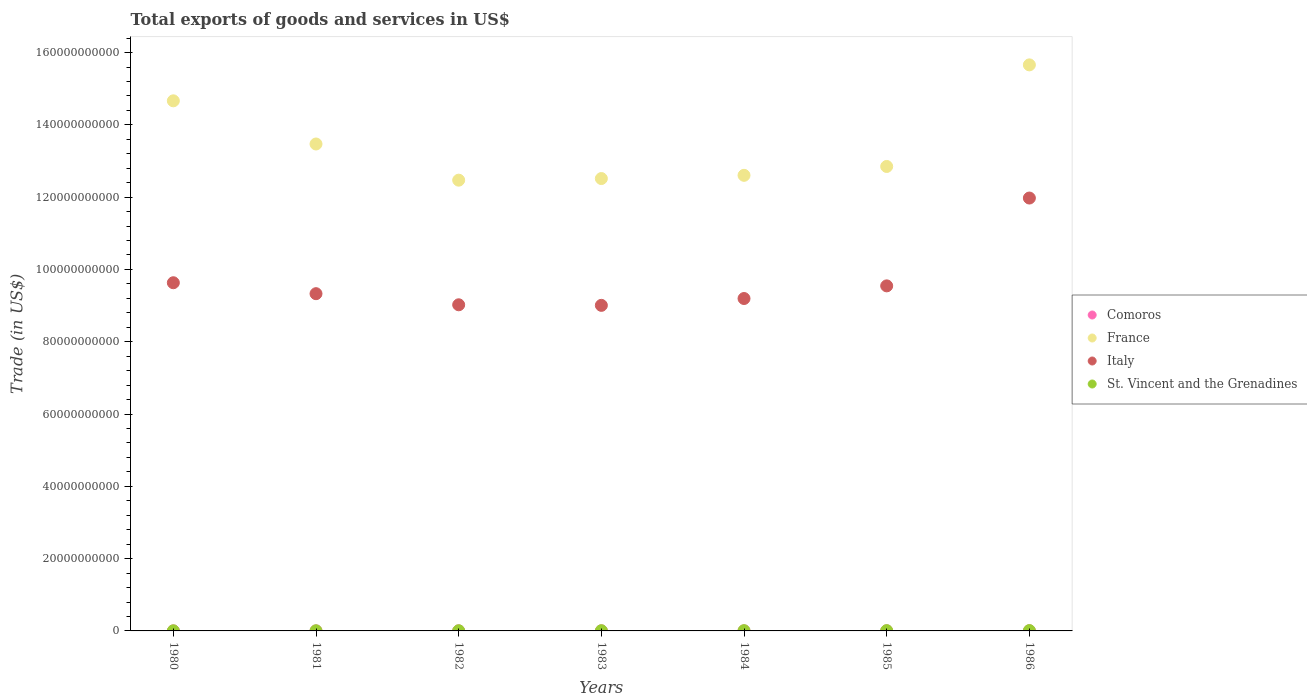Is the number of dotlines equal to the number of legend labels?
Offer a very short reply. Yes. What is the total exports of goods and services in St. Vincent and the Grenadines in 1984?
Your answer should be compact. 7.15e+07. Across all years, what is the maximum total exports of goods and services in Italy?
Offer a very short reply. 1.20e+11. Across all years, what is the minimum total exports of goods and services in Italy?
Offer a terse response. 9.01e+1. In which year was the total exports of goods and services in Italy maximum?
Offer a terse response. 1986. What is the total total exports of goods and services in France in the graph?
Provide a short and direct response. 9.42e+11. What is the difference between the total exports of goods and services in Italy in 1983 and that in 1986?
Offer a terse response. -2.97e+1. What is the difference between the total exports of goods and services in St. Vincent and the Grenadines in 1984 and the total exports of goods and services in Comoros in 1983?
Provide a short and direct response. 4.94e+07. What is the average total exports of goods and services in France per year?
Your response must be concise. 1.35e+11. In the year 1986, what is the difference between the total exports of goods and services in Comoros and total exports of goods and services in France?
Your answer should be very brief. -1.57e+11. In how many years, is the total exports of goods and services in France greater than 116000000000 US$?
Provide a succinct answer. 7. What is the ratio of the total exports of goods and services in Comoros in 1983 to that in 1984?
Keep it short and to the point. 2.28. Is the total exports of goods and services in France in 1981 less than that in 1982?
Your response must be concise. No. Is the difference between the total exports of goods and services in Comoros in 1983 and 1985 greater than the difference between the total exports of goods and services in France in 1983 and 1985?
Offer a very short reply. Yes. What is the difference between the highest and the second highest total exports of goods and services in Comoros?
Provide a short and direct response. 4.60e+06. What is the difference between the highest and the lowest total exports of goods and services in France?
Your response must be concise. 3.19e+1. In how many years, is the total exports of goods and services in Italy greater than the average total exports of goods and services in Italy taken over all years?
Your answer should be very brief. 1. Is it the case that in every year, the sum of the total exports of goods and services in Italy and total exports of goods and services in France  is greater than the sum of total exports of goods and services in St. Vincent and the Grenadines and total exports of goods and services in Comoros?
Offer a very short reply. No. Is it the case that in every year, the sum of the total exports of goods and services in St. Vincent and the Grenadines and total exports of goods and services in France  is greater than the total exports of goods and services in Comoros?
Give a very brief answer. Yes. Does the total exports of goods and services in France monotonically increase over the years?
Keep it short and to the point. No. How many dotlines are there?
Make the answer very short. 4. How many years are there in the graph?
Your answer should be compact. 7. Does the graph contain grids?
Provide a succinct answer. No. How many legend labels are there?
Provide a succinct answer. 4. How are the legend labels stacked?
Ensure brevity in your answer.  Vertical. What is the title of the graph?
Ensure brevity in your answer.  Total exports of goods and services in US$. Does "New Caledonia" appear as one of the legend labels in the graph?
Ensure brevity in your answer.  No. What is the label or title of the X-axis?
Offer a very short reply. Years. What is the label or title of the Y-axis?
Your answer should be compact. Trade (in US$). What is the Trade (in US$) in Comoros in 1980?
Make the answer very short. 1.07e+07. What is the Trade (in US$) of France in 1980?
Ensure brevity in your answer.  1.47e+11. What is the Trade (in US$) of Italy in 1980?
Give a very brief answer. 9.63e+1. What is the Trade (in US$) in St. Vincent and the Grenadines in 1980?
Offer a very short reply. 3.31e+07. What is the Trade (in US$) in Comoros in 1981?
Your answer should be compact. 1.34e+07. What is the Trade (in US$) of France in 1981?
Provide a short and direct response. 1.35e+11. What is the Trade (in US$) of Italy in 1981?
Your answer should be compact. 9.33e+1. What is the Trade (in US$) of St. Vincent and the Grenadines in 1981?
Make the answer very short. 4.30e+07. What is the Trade (in US$) of Comoros in 1982?
Provide a short and direct response. 1.68e+07. What is the Trade (in US$) in France in 1982?
Provide a succinct answer. 1.25e+11. What is the Trade (in US$) of Italy in 1982?
Provide a succinct answer. 9.02e+1. What is the Trade (in US$) of St. Vincent and the Grenadines in 1982?
Give a very brief answer. 5.03e+07. What is the Trade (in US$) of Comoros in 1983?
Keep it short and to the point. 2.21e+07. What is the Trade (in US$) in France in 1983?
Your response must be concise. 1.25e+11. What is the Trade (in US$) in Italy in 1983?
Offer a very short reply. 9.01e+1. What is the Trade (in US$) in St. Vincent and the Grenadines in 1983?
Provide a succinct answer. 5.77e+07. What is the Trade (in US$) of Comoros in 1984?
Your answer should be compact. 9.69e+06. What is the Trade (in US$) of France in 1984?
Offer a terse response. 1.26e+11. What is the Trade (in US$) of Italy in 1984?
Offer a terse response. 9.20e+1. What is the Trade (in US$) of St. Vincent and the Grenadines in 1984?
Provide a succinct answer. 7.15e+07. What is the Trade (in US$) of Comoros in 1985?
Ensure brevity in your answer.  1.95e+07. What is the Trade (in US$) in France in 1985?
Offer a terse response. 1.28e+11. What is the Trade (in US$) in Italy in 1985?
Keep it short and to the point. 9.55e+1. What is the Trade (in US$) in St. Vincent and the Grenadines in 1985?
Your response must be concise. 8.24e+07. What is the Trade (in US$) in Comoros in 1986?
Ensure brevity in your answer.  2.67e+07. What is the Trade (in US$) in France in 1986?
Offer a terse response. 1.57e+11. What is the Trade (in US$) of Italy in 1986?
Your answer should be very brief. 1.20e+11. What is the Trade (in US$) of St. Vincent and the Grenadines in 1986?
Keep it short and to the point. 9.29e+07. Across all years, what is the maximum Trade (in US$) of Comoros?
Give a very brief answer. 2.67e+07. Across all years, what is the maximum Trade (in US$) in France?
Offer a terse response. 1.57e+11. Across all years, what is the maximum Trade (in US$) of Italy?
Provide a succinct answer. 1.20e+11. Across all years, what is the maximum Trade (in US$) in St. Vincent and the Grenadines?
Your response must be concise. 9.29e+07. Across all years, what is the minimum Trade (in US$) in Comoros?
Your response must be concise. 9.69e+06. Across all years, what is the minimum Trade (in US$) of France?
Your response must be concise. 1.25e+11. Across all years, what is the minimum Trade (in US$) in Italy?
Give a very brief answer. 9.01e+1. Across all years, what is the minimum Trade (in US$) of St. Vincent and the Grenadines?
Your answer should be compact. 3.31e+07. What is the total Trade (in US$) of Comoros in the graph?
Provide a succinct answer. 1.19e+08. What is the total Trade (in US$) in France in the graph?
Your response must be concise. 9.42e+11. What is the total Trade (in US$) in Italy in the graph?
Give a very brief answer. 6.77e+11. What is the total Trade (in US$) of St. Vincent and the Grenadines in the graph?
Give a very brief answer. 4.31e+08. What is the difference between the Trade (in US$) of Comoros in 1980 and that in 1981?
Make the answer very short. -2.69e+06. What is the difference between the Trade (in US$) in France in 1980 and that in 1981?
Make the answer very short. 1.19e+1. What is the difference between the Trade (in US$) of Italy in 1980 and that in 1981?
Offer a very short reply. 3.03e+09. What is the difference between the Trade (in US$) in St. Vincent and the Grenadines in 1980 and that in 1981?
Your answer should be compact. -9.82e+06. What is the difference between the Trade (in US$) in Comoros in 1980 and that in 1982?
Your answer should be very brief. -6.05e+06. What is the difference between the Trade (in US$) in France in 1980 and that in 1982?
Provide a succinct answer. 2.19e+1. What is the difference between the Trade (in US$) of Italy in 1980 and that in 1982?
Offer a terse response. 6.10e+09. What is the difference between the Trade (in US$) of St. Vincent and the Grenadines in 1980 and that in 1982?
Ensure brevity in your answer.  -1.72e+07. What is the difference between the Trade (in US$) of Comoros in 1980 and that in 1983?
Ensure brevity in your answer.  -1.14e+07. What is the difference between the Trade (in US$) of France in 1980 and that in 1983?
Provide a short and direct response. 2.15e+1. What is the difference between the Trade (in US$) in Italy in 1980 and that in 1983?
Ensure brevity in your answer.  6.25e+09. What is the difference between the Trade (in US$) in St. Vincent and the Grenadines in 1980 and that in 1983?
Offer a terse response. -2.45e+07. What is the difference between the Trade (in US$) of Comoros in 1980 and that in 1984?
Your answer should be very brief. 1.05e+06. What is the difference between the Trade (in US$) in France in 1980 and that in 1984?
Provide a short and direct response. 2.06e+1. What is the difference between the Trade (in US$) of Italy in 1980 and that in 1984?
Offer a very short reply. 4.36e+09. What is the difference between the Trade (in US$) of St. Vincent and the Grenadines in 1980 and that in 1984?
Ensure brevity in your answer.  -3.83e+07. What is the difference between the Trade (in US$) of Comoros in 1980 and that in 1985?
Make the answer very short. -8.72e+06. What is the difference between the Trade (in US$) of France in 1980 and that in 1985?
Provide a succinct answer. 1.82e+1. What is the difference between the Trade (in US$) in Italy in 1980 and that in 1985?
Your answer should be compact. 8.65e+08. What is the difference between the Trade (in US$) of St. Vincent and the Grenadines in 1980 and that in 1985?
Your response must be concise. -4.93e+07. What is the difference between the Trade (in US$) of Comoros in 1980 and that in 1986?
Your response must be concise. -1.60e+07. What is the difference between the Trade (in US$) of France in 1980 and that in 1986?
Your answer should be very brief. -9.95e+09. What is the difference between the Trade (in US$) in Italy in 1980 and that in 1986?
Your answer should be very brief. -2.34e+1. What is the difference between the Trade (in US$) of St. Vincent and the Grenadines in 1980 and that in 1986?
Offer a very short reply. -5.98e+07. What is the difference between the Trade (in US$) in Comoros in 1981 and that in 1982?
Your answer should be compact. -3.36e+06. What is the difference between the Trade (in US$) of France in 1981 and that in 1982?
Ensure brevity in your answer.  1.00e+1. What is the difference between the Trade (in US$) of Italy in 1981 and that in 1982?
Make the answer very short. 3.07e+09. What is the difference between the Trade (in US$) in St. Vincent and the Grenadines in 1981 and that in 1982?
Provide a succinct answer. -7.39e+06. What is the difference between the Trade (in US$) of Comoros in 1981 and that in 1983?
Give a very brief answer. -8.68e+06. What is the difference between the Trade (in US$) in France in 1981 and that in 1983?
Ensure brevity in your answer.  9.56e+09. What is the difference between the Trade (in US$) in Italy in 1981 and that in 1983?
Provide a short and direct response. 3.23e+09. What is the difference between the Trade (in US$) in St. Vincent and the Grenadines in 1981 and that in 1983?
Ensure brevity in your answer.  -1.47e+07. What is the difference between the Trade (in US$) in Comoros in 1981 and that in 1984?
Offer a terse response. 3.74e+06. What is the difference between the Trade (in US$) in France in 1981 and that in 1984?
Make the answer very short. 8.67e+09. What is the difference between the Trade (in US$) in Italy in 1981 and that in 1984?
Provide a short and direct response. 1.34e+09. What is the difference between the Trade (in US$) in St. Vincent and the Grenadines in 1981 and that in 1984?
Offer a very short reply. -2.85e+07. What is the difference between the Trade (in US$) in Comoros in 1981 and that in 1985?
Make the answer very short. -6.02e+06. What is the difference between the Trade (in US$) in France in 1981 and that in 1985?
Your answer should be compact. 6.22e+09. What is the difference between the Trade (in US$) in Italy in 1981 and that in 1985?
Your answer should be compact. -2.16e+09. What is the difference between the Trade (in US$) in St. Vincent and the Grenadines in 1981 and that in 1985?
Keep it short and to the point. -3.94e+07. What is the difference between the Trade (in US$) of Comoros in 1981 and that in 1986?
Your response must be concise. -1.33e+07. What is the difference between the Trade (in US$) of France in 1981 and that in 1986?
Make the answer very short. -2.19e+1. What is the difference between the Trade (in US$) of Italy in 1981 and that in 1986?
Your response must be concise. -2.65e+1. What is the difference between the Trade (in US$) in St. Vincent and the Grenadines in 1981 and that in 1986?
Provide a succinct answer. -4.99e+07. What is the difference between the Trade (in US$) of Comoros in 1982 and that in 1983?
Offer a very short reply. -5.31e+06. What is the difference between the Trade (in US$) of France in 1982 and that in 1983?
Keep it short and to the point. -4.46e+08. What is the difference between the Trade (in US$) of Italy in 1982 and that in 1983?
Offer a terse response. 1.56e+08. What is the difference between the Trade (in US$) of St. Vincent and the Grenadines in 1982 and that in 1983?
Provide a short and direct response. -7.34e+06. What is the difference between the Trade (in US$) of Comoros in 1982 and that in 1984?
Make the answer very short. 7.10e+06. What is the difference between the Trade (in US$) of France in 1982 and that in 1984?
Your answer should be very brief. -1.34e+09. What is the difference between the Trade (in US$) of Italy in 1982 and that in 1984?
Make the answer very short. -1.74e+09. What is the difference between the Trade (in US$) of St. Vincent and the Grenadines in 1982 and that in 1984?
Your response must be concise. -2.11e+07. What is the difference between the Trade (in US$) in Comoros in 1982 and that in 1985?
Make the answer very short. -2.66e+06. What is the difference between the Trade (in US$) of France in 1982 and that in 1985?
Ensure brevity in your answer.  -3.79e+09. What is the difference between the Trade (in US$) in Italy in 1982 and that in 1985?
Your response must be concise. -5.23e+09. What is the difference between the Trade (in US$) of St. Vincent and the Grenadines in 1982 and that in 1985?
Offer a terse response. -3.21e+07. What is the difference between the Trade (in US$) in Comoros in 1982 and that in 1986?
Offer a terse response. -9.92e+06. What is the difference between the Trade (in US$) in France in 1982 and that in 1986?
Provide a short and direct response. -3.19e+1. What is the difference between the Trade (in US$) in Italy in 1982 and that in 1986?
Your answer should be compact. -2.95e+1. What is the difference between the Trade (in US$) in St. Vincent and the Grenadines in 1982 and that in 1986?
Your response must be concise. -4.25e+07. What is the difference between the Trade (in US$) of Comoros in 1983 and that in 1984?
Offer a terse response. 1.24e+07. What is the difference between the Trade (in US$) in France in 1983 and that in 1984?
Your answer should be compact. -8.93e+08. What is the difference between the Trade (in US$) in Italy in 1983 and that in 1984?
Make the answer very short. -1.89e+09. What is the difference between the Trade (in US$) in St. Vincent and the Grenadines in 1983 and that in 1984?
Give a very brief answer. -1.38e+07. What is the difference between the Trade (in US$) of Comoros in 1983 and that in 1985?
Make the answer very short. 2.65e+06. What is the difference between the Trade (in US$) in France in 1983 and that in 1985?
Provide a short and direct response. -3.35e+09. What is the difference between the Trade (in US$) in Italy in 1983 and that in 1985?
Offer a very short reply. -5.39e+09. What is the difference between the Trade (in US$) in St. Vincent and the Grenadines in 1983 and that in 1985?
Provide a succinct answer. -2.47e+07. What is the difference between the Trade (in US$) in Comoros in 1983 and that in 1986?
Give a very brief answer. -4.60e+06. What is the difference between the Trade (in US$) of France in 1983 and that in 1986?
Provide a succinct answer. -3.14e+1. What is the difference between the Trade (in US$) of Italy in 1983 and that in 1986?
Your answer should be compact. -2.97e+1. What is the difference between the Trade (in US$) in St. Vincent and the Grenadines in 1983 and that in 1986?
Ensure brevity in your answer.  -3.52e+07. What is the difference between the Trade (in US$) in Comoros in 1984 and that in 1985?
Offer a terse response. -9.77e+06. What is the difference between the Trade (in US$) of France in 1984 and that in 1985?
Offer a terse response. -2.45e+09. What is the difference between the Trade (in US$) in Italy in 1984 and that in 1985?
Ensure brevity in your answer.  -3.50e+09. What is the difference between the Trade (in US$) of St. Vincent and the Grenadines in 1984 and that in 1985?
Your response must be concise. -1.09e+07. What is the difference between the Trade (in US$) of Comoros in 1984 and that in 1986?
Offer a very short reply. -1.70e+07. What is the difference between the Trade (in US$) in France in 1984 and that in 1986?
Your answer should be compact. -3.06e+1. What is the difference between the Trade (in US$) in Italy in 1984 and that in 1986?
Offer a very short reply. -2.78e+1. What is the difference between the Trade (in US$) in St. Vincent and the Grenadines in 1984 and that in 1986?
Provide a succinct answer. -2.14e+07. What is the difference between the Trade (in US$) of Comoros in 1985 and that in 1986?
Keep it short and to the point. -7.25e+06. What is the difference between the Trade (in US$) in France in 1985 and that in 1986?
Your response must be concise. -2.81e+1. What is the difference between the Trade (in US$) of Italy in 1985 and that in 1986?
Provide a short and direct response. -2.43e+1. What is the difference between the Trade (in US$) in St. Vincent and the Grenadines in 1985 and that in 1986?
Make the answer very short. -1.05e+07. What is the difference between the Trade (in US$) in Comoros in 1980 and the Trade (in US$) in France in 1981?
Provide a succinct answer. -1.35e+11. What is the difference between the Trade (in US$) in Comoros in 1980 and the Trade (in US$) in Italy in 1981?
Your answer should be very brief. -9.33e+1. What is the difference between the Trade (in US$) in Comoros in 1980 and the Trade (in US$) in St. Vincent and the Grenadines in 1981?
Offer a terse response. -3.22e+07. What is the difference between the Trade (in US$) in France in 1980 and the Trade (in US$) in Italy in 1981?
Make the answer very short. 5.34e+1. What is the difference between the Trade (in US$) of France in 1980 and the Trade (in US$) of St. Vincent and the Grenadines in 1981?
Your response must be concise. 1.47e+11. What is the difference between the Trade (in US$) in Italy in 1980 and the Trade (in US$) in St. Vincent and the Grenadines in 1981?
Your answer should be compact. 9.63e+1. What is the difference between the Trade (in US$) in Comoros in 1980 and the Trade (in US$) in France in 1982?
Offer a terse response. -1.25e+11. What is the difference between the Trade (in US$) of Comoros in 1980 and the Trade (in US$) of Italy in 1982?
Offer a very short reply. -9.02e+1. What is the difference between the Trade (in US$) of Comoros in 1980 and the Trade (in US$) of St. Vincent and the Grenadines in 1982?
Your response must be concise. -3.96e+07. What is the difference between the Trade (in US$) of France in 1980 and the Trade (in US$) of Italy in 1982?
Offer a very short reply. 5.64e+1. What is the difference between the Trade (in US$) of France in 1980 and the Trade (in US$) of St. Vincent and the Grenadines in 1982?
Make the answer very short. 1.47e+11. What is the difference between the Trade (in US$) in Italy in 1980 and the Trade (in US$) in St. Vincent and the Grenadines in 1982?
Give a very brief answer. 9.63e+1. What is the difference between the Trade (in US$) in Comoros in 1980 and the Trade (in US$) in France in 1983?
Keep it short and to the point. -1.25e+11. What is the difference between the Trade (in US$) of Comoros in 1980 and the Trade (in US$) of Italy in 1983?
Offer a very short reply. -9.01e+1. What is the difference between the Trade (in US$) of Comoros in 1980 and the Trade (in US$) of St. Vincent and the Grenadines in 1983?
Offer a terse response. -4.69e+07. What is the difference between the Trade (in US$) of France in 1980 and the Trade (in US$) of Italy in 1983?
Make the answer very short. 5.66e+1. What is the difference between the Trade (in US$) in France in 1980 and the Trade (in US$) in St. Vincent and the Grenadines in 1983?
Give a very brief answer. 1.47e+11. What is the difference between the Trade (in US$) of Italy in 1980 and the Trade (in US$) of St. Vincent and the Grenadines in 1983?
Make the answer very short. 9.63e+1. What is the difference between the Trade (in US$) in Comoros in 1980 and the Trade (in US$) in France in 1984?
Keep it short and to the point. -1.26e+11. What is the difference between the Trade (in US$) in Comoros in 1980 and the Trade (in US$) in Italy in 1984?
Keep it short and to the point. -9.19e+1. What is the difference between the Trade (in US$) in Comoros in 1980 and the Trade (in US$) in St. Vincent and the Grenadines in 1984?
Provide a succinct answer. -6.07e+07. What is the difference between the Trade (in US$) of France in 1980 and the Trade (in US$) of Italy in 1984?
Offer a terse response. 5.47e+1. What is the difference between the Trade (in US$) in France in 1980 and the Trade (in US$) in St. Vincent and the Grenadines in 1984?
Provide a succinct answer. 1.47e+11. What is the difference between the Trade (in US$) in Italy in 1980 and the Trade (in US$) in St. Vincent and the Grenadines in 1984?
Your answer should be compact. 9.62e+1. What is the difference between the Trade (in US$) in Comoros in 1980 and the Trade (in US$) in France in 1985?
Give a very brief answer. -1.28e+11. What is the difference between the Trade (in US$) of Comoros in 1980 and the Trade (in US$) of Italy in 1985?
Keep it short and to the point. -9.54e+1. What is the difference between the Trade (in US$) of Comoros in 1980 and the Trade (in US$) of St. Vincent and the Grenadines in 1985?
Your response must be concise. -7.17e+07. What is the difference between the Trade (in US$) in France in 1980 and the Trade (in US$) in Italy in 1985?
Provide a short and direct response. 5.12e+1. What is the difference between the Trade (in US$) of France in 1980 and the Trade (in US$) of St. Vincent and the Grenadines in 1985?
Your answer should be very brief. 1.47e+11. What is the difference between the Trade (in US$) of Italy in 1980 and the Trade (in US$) of St. Vincent and the Grenadines in 1985?
Keep it short and to the point. 9.62e+1. What is the difference between the Trade (in US$) of Comoros in 1980 and the Trade (in US$) of France in 1986?
Provide a short and direct response. -1.57e+11. What is the difference between the Trade (in US$) in Comoros in 1980 and the Trade (in US$) in Italy in 1986?
Provide a short and direct response. -1.20e+11. What is the difference between the Trade (in US$) in Comoros in 1980 and the Trade (in US$) in St. Vincent and the Grenadines in 1986?
Give a very brief answer. -8.21e+07. What is the difference between the Trade (in US$) of France in 1980 and the Trade (in US$) of Italy in 1986?
Your answer should be compact. 2.69e+1. What is the difference between the Trade (in US$) in France in 1980 and the Trade (in US$) in St. Vincent and the Grenadines in 1986?
Make the answer very short. 1.47e+11. What is the difference between the Trade (in US$) of Italy in 1980 and the Trade (in US$) of St. Vincent and the Grenadines in 1986?
Make the answer very short. 9.62e+1. What is the difference between the Trade (in US$) in Comoros in 1981 and the Trade (in US$) in France in 1982?
Give a very brief answer. -1.25e+11. What is the difference between the Trade (in US$) in Comoros in 1981 and the Trade (in US$) in Italy in 1982?
Make the answer very short. -9.02e+1. What is the difference between the Trade (in US$) of Comoros in 1981 and the Trade (in US$) of St. Vincent and the Grenadines in 1982?
Give a very brief answer. -3.69e+07. What is the difference between the Trade (in US$) in France in 1981 and the Trade (in US$) in Italy in 1982?
Your answer should be very brief. 4.45e+1. What is the difference between the Trade (in US$) in France in 1981 and the Trade (in US$) in St. Vincent and the Grenadines in 1982?
Offer a very short reply. 1.35e+11. What is the difference between the Trade (in US$) of Italy in 1981 and the Trade (in US$) of St. Vincent and the Grenadines in 1982?
Offer a terse response. 9.32e+1. What is the difference between the Trade (in US$) in Comoros in 1981 and the Trade (in US$) in France in 1983?
Provide a succinct answer. -1.25e+11. What is the difference between the Trade (in US$) of Comoros in 1981 and the Trade (in US$) of Italy in 1983?
Your answer should be very brief. -9.01e+1. What is the difference between the Trade (in US$) in Comoros in 1981 and the Trade (in US$) in St. Vincent and the Grenadines in 1983?
Your response must be concise. -4.42e+07. What is the difference between the Trade (in US$) of France in 1981 and the Trade (in US$) of Italy in 1983?
Make the answer very short. 4.46e+1. What is the difference between the Trade (in US$) of France in 1981 and the Trade (in US$) of St. Vincent and the Grenadines in 1983?
Ensure brevity in your answer.  1.35e+11. What is the difference between the Trade (in US$) in Italy in 1981 and the Trade (in US$) in St. Vincent and the Grenadines in 1983?
Your answer should be very brief. 9.32e+1. What is the difference between the Trade (in US$) of Comoros in 1981 and the Trade (in US$) of France in 1984?
Give a very brief answer. -1.26e+11. What is the difference between the Trade (in US$) in Comoros in 1981 and the Trade (in US$) in Italy in 1984?
Provide a succinct answer. -9.19e+1. What is the difference between the Trade (in US$) in Comoros in 1981 and the Trade (in US$) in St. Vincent and the Grenadines in 1984?
Keep it short and to the point. -5.80e+07. What is the difference between the Trade (in US$) in France in 1981 and the Trade (in US$) in Italy in 1984?
Your response must be concise. 4.27e+1. What is the difference between the Trade (in US$) of France in 1981 and the Trade (in US$) of St. Vincent and the Grenadines in 1984?
Provide a succinct answer. 1.35e+11. What is the difference between the Trade (in US$) of Italy in 1981 and the Trade (in US$) of St. Vincent and the Grenadines in 1984?
Offer a terse response. 9.32e+1. What is the difference between the Trade (in US$) in Comoros in 1981 and the Trade (in US$) in France in 1985?
Make the answer very short. -1.28e+11. What is the difference between the Trade (in US$) of Comoros in 1981 and the Trade (in US$) of Italy in 1985?
Offer a terse response. -9.54e+1. What is the difference between the Trade (in US$) in Comoros in 1981 and the Trade (in US$) in St. Vincent and the Grenadines in 1985?
Offer a very short reply. -6.90e+07. What is the difference between the Trade (in US$) of France in 1981 and the Trade (in US$) of Italy in 1985?
Ensure brevity in your answer.  3.92e+1. What is the difference between the Trade (in US$) of France in 1981 and the Trade (in US$) of St. Vincent and the Grenadines in 1985?
Ensure brevity in your answer.  1.35e+11. What is the difference between the Trade (in US$) of Italy in 1981 and the Trade (in US$) of St. Vincent and the Grenadines in 1985?
Offer a terse response. 9.32e+1. What is the difference between the Trade (in US$) in Comoros in 1981 and the Trade (in US$) in France in 1986?
Make the answer very short. -1.57e+11. What is the difference between the Trade (in US$) of Comoros in 1981 and the Trade (in US$) of Italy in 1986?
Your answer should be very brief. -1.20e+11. What is the difference between the Trade (in US$) in Comoros in 1981 and the Trade (in US$) in St. Vincent and the Grenadines in 1986?
Your answer should be very brief. -7.95e+07. What is the difference between the Trade (in US$) in France in 1981 and the Trade (in US$) in Italy in 1986?
Your answer should be compact. 1.50e+1. What is the difference between the Trade (in US$) in France in 1981 and the Trade (in US$) in St. Vincent and the Grenadines in 1986?
Give a very brief answer. 1.35e+11. What is the difference between the Trade (in US$) in Italy in 1981 and the Trade (in US$) in St. Vincent and the Grenadines in 1986?
Offer a terse response. 9.32e+1. What is the difference between the Trade (in US$) of Comoros in 1982 and the Trade (in US$) of France in 1983?
Provide a succinct answer. -1.25e+11. What is the difference between the Trade (in US$) of Comoros in 1982 and the Trade (in US$) of Italy in 1983?
Give a very brief answer. -9.00e+1. What is the difference between the Trade (in US$) of Comoros in 1982 and the Trade (in US$) of St. Vincent and the Grenadines in 1983?
Provide a succinct answer. -4.09e+07. What is the difference between the Trade (in US$) in France in 1982 and the Trade (in US$) in Italy in 1983?
Keep it short and to the point. 3.46e+1. What is the difference between the Trade (in US$) in France in 1982 and the Trade (in US$) in St. Vincent and the Grenadines in 1983?
Keep it short and to the point. 1.25e+11. What is the difference between the Trade (in US$) of Italy in 1982 and the Trade (in US$) of St. Vincent and the Grenadines in 1983?
Provide a succinct answer. 9.02e+1. What is the difference between the Trade (in US$) of Comoros in 1982 and the Trade (in US$) of France in 1984?
Your answer should be very brief. -1.26e+11. What is the difference between the Trade (in US$) of Comoros in 1982 and the Trade (in US$) of Italy in 1984?
Your response must be concise. -9.19e+1. What is the difference between the Trade (in US$) in Comoros in 1982 and the Trade (in US$) in St. Vincent and the Grenadines in 1984?
Give a very brief answer. -5.47e+07. What is the difference between the Trade (in US$) of France in 1982 and the Trade (in US$) of Italy in 1984?
Offer a terse response. 3.27e+1. What is the difference between the Trade (in US$) in France in 1982 and the Trade (in US$) in St. Vincent and the Grenadines in 1984?
Provide a short and direct response. 1.25e+11. What is the difference between the Trade (in US$) in Italy in 1982 and the Trade (in US$) in St. Vincent and the Grenadines in 1984?
Your answer should be very brief. 9.02e+1. What is the difference between the Trade (in US$) of Comoros in 1982 and the Trade (in US$) of France in 1985?
Provide a succinct answer. -1.28e+11. What is the difference between the Trade (in US$) in Comoros in 1982 and the Trade (in US$) in Italy in 1985?
Offer a terse response. -9.54e+1. What is the difference between the Trade (in US$) of Comoros in 1982 and the Trade (in US$) of St. Vincent and the Grenadines in 1985?
Ensure brevity in your answer.  -6.56e+07. What is the difference between the Trade (in US$) of France in 1982 and the Trade (in US$) of Italy in 1985?
Offer a terse response. 2.92e+1. What is the difference between the Trade (in US$) in France in 1982 and the Trade (in US$) in St. Vincent and the Grenadines in 1985?
Offer a terse response. 1.25e+11. What is the difference between the Trade (in US$) in Italy in 1982 and the Trade (in US$) in St. Vincent and the Grenadines in 1985?
Offer a very short reply. 9.01e+1. What is the difference between the Trade (in US$) of Comoros in 1982 and the Trade (in US$) of France in 1986?
Give a very brief answer. -1.57e+11. What is the difference between the Trade (in US$) of Comoros in 1982 and the Trade (in US$) of Italy in 1986?
Ensure brevity in your answer.  -1.20e+11. What is the difference between the Trade (in US$) in Comoros in 1982 and the Trade (in US$) in St. Vincent and the Grenadines in 1986?
Ensure brevity in your answer.  -7.61e+07. What is the difference between the Trade (in US$) in France in 1982 and the Trade (in US$) in Italy in 1986?
Give a very brief answer. 4.94e+09. What is the difference between the Trade (in US$) in France in 1982 and the Trade (in US$) in St. Vincent and the Grenadines in 1986?
Give a very brief answer. 1.25e+11. What is the difference between the Trade (in US$) in Italy in 1982 and the Trade (in US$) in St. Vincent and the Grenadines in 1986?
Offer a terse response. 9.01e+1. What is the difference between the Trade (in US$) in Comoros in 1983 and the Trade (in US$) in France in 1984?
Provide a short and direct response. -1.26e+11. What is the difference between the Trade (in US$) of Comoros in 1983 and the Trade (in US$) of Italy in 1984?
Ensure brevity in your answer.  -9.19e+1. What is the difference between the Trade (in US$) of Comoros in 1983 and the Trade (in US$) of St. Vincent and the Grenadines in 1984?
Offer a very short reply. -4.94e+07. What is the difference between the Trade (in US$) in France in 1983 and the Trade (in US$) in Italy in 1984?
Offer a very short reply. 3.32e+1. What is the difference between the Trade (in US$) of France in 1983 and the Trade (in US$) of St. Vincent and the Grenadines in 1984?
Your response must be concise. 1.25e+11. What is the difference between the Trade (in US$) of Italy in 1983 and the Trade (in US$) of St. Vincent and the Grenadines in 1984?
Keep it short and to the point. 9.00e+1. What is the difference between the Trade (in US$) in Comoros in 1983 and the Trade (in US$) in France in 1985?
Your answer should be very brief. -1.28e+11. What is the difference between the Trade (in US$) of Comoros in 1983 and the Trade (in US$) of Italy in 1985?
Provide a succinct answer. -9.54e+1. What is the difference between the Trade (in US$) in Comoros in 1983 and the Trade (in US$) in St. Vincent and the Grenadines in 1985?
Offer a terse response. -6.03e+07. What is the difference between the Trade (in US$) in France in 1983 and the Trade (in US$) in Italy in 1985?
Offer a terse response. 2.97e+1. What is the difference between the Trade (in US$) of France in 1983 and the Trade (in US$) of St. Vincent and the Grenadines in 1985?
Provide a succinct answer. 1.25e+11. What is the difference between the Trade (in US$) of Italy in 1983 and the Trade (in US$) of St. Vincent and the Grenadines in 1985?
Your answer should be compact. 9.00e+1. What is the difference between the Trade (in US$) in Comoros in 1983 and the Trade (in US$) in France in 1986?
Offer a very short reply. -1.57e+11. What is the difference between the Trade (in US$) of Comoros in 1983 and the Trade (in US$) of Italy in 1986?
Provide a succinct answer. -1.20e+11. What is the difference between the Trade (in US$) in Comoros in 1983 and the Trade (in US$) in St. Vincent and the Grenadines in 1986?
Give a very brief answer. -7.08e+07. What is the difference between the Trade (in US$) of France in 1983 and the Trade (in US$) of Italy in 1986?
Offer a terse response. 5.39e+09. What is the difference between the Trade (in US$) of France in 1983 and the Trade (in US$) of St. Vincent and the Grenadines in 1986?
Keep it short and to the point. 1.25e+11. What is the difference between the Trade (in US$) in Italy in 1983 and the Trade (in US$) in St. Vincent and the Grenadines in 1986?
Provide a succinct answer. 9.00e+1. What is the difference between the Trade (in US$) of Comoros in 1984 and the Trade (in US$) of France in 1985?
Offer a terse response. -1.28e+11. What is the difference between the Trade (in US$) in Comoros in 1984 and the Trade (in US$) in Italy in 1985?
Ensure brevity in your answer.  -9.54e+1. What is the difference between the Trade (in US$) of Comoros in 1984 and the Trade (in US$) of St. Vincent and the Grenadines in 1985?
Offer a very short reply. -7.27e+07. What is the difference between the Trade (in US$) of France in 1984 and the Trade (in US$) of Italy in 1985?
Your answer should be very brief. 3.06e+1. What is the difference between the Trade (in US$) of France in 1984 and the Trade (in US$) of St. Vincent and the Grenadines in 1985?
Offer a very short reply. 1.26e+11. What is the difference between the Trade (in US$) of Italy in 1984 and the Trade (in US$) of St. Vincent and the Grenadines in 1985?
Offer a very short reply. 9.19e+1. What is the difference between the Trade (in US$) of Comoros in 1984 and the Trade (in US$) of France in 1986?
Keep it short and to the point. -1.57e+11. What is the difference between the Trade (in US$) in Comoros in 1984 and the Trade (in US$) in Italy in 1986?
Give a very brief answer. -1.20e+11. What is the difference between the Trade (in US$) of Comoros in 1984 and the Trade (in US$) of St. Vincent and the Grenadines in 1986?
Your answer should be compact. -8.32e+07. What is the difference between the Trade (in US$) of France in 1984 and the Trade (in US$) of Italy in 1986?
Give a very brief answer. 6.28e+09. What is the difference between the Trade (in US$) in France in 1984 and the Trade (in US$) in St. Vincent and the Grenadines in 1986?
Provide a short and direct response. 1.26e+11. What is the difference between the Trade (in US$) of Italy in 1984 and the Trade (in US$) of St. Vincent and the Grenadines in 1986?
Keep it short and to the point. 9.19e+1. What is the difference between the Trade (in US$) in Comoros in 1985 and the Trade (in US$) in France in 1986?
Give a very brief answer. -1.57e+11. What is the difference between the Trade (in US$) of Comoros in 1985 and the Trade (in US$) of Italy in 1986?
Your answer should be very brief. -1.20e+11. What is the difference between the Trade (in US$) of Comoros in 1985 and the Trade (in US$) of St. Vincent and the Grenadines in 1986?
Keep it short and to the point. -7.34e+07. What is the difference between the Trade (in US$) in France in 1985 and the Trade (in US$) in Italy in 1986?
Give a very brief answer. 8.74e+09. What is the difference between the Trade (in US$) of France in 1985 and the Trade (in US$) of St. Vincent and the Grenadines in 1986?
Make the answer very short. 1.28e+11. What is the difference between the Trade (in US$) in Italy in 1985 and the Trade (in US$) in St. Vincent and the Grenadines in 1986?
Provide a short and direct response. 9.54e+1. What is the average Trade (in US$) in Comoros per year?
Provide a short and direct response. 1.70e+07. What is the average Trade (in US$) of France per year?
Provide a succinct answer. 1.35e+11. What is the average Trade (in US$) in Italy per year?
Offer a terse response. 9.67e+1. What is the average Trade (in US$) in St. Vincent and the Grenadines per year?
Give a very brief answer. 6.16e+07. In the year 1980, what is the difference between the Trade (in US$) of Comoros and Trade (in US$) of France?
Give a very brief answer. -1.47e+11. In the year 1980, what is the difference between the Trade (in US$) in Comoros and Trade (in US$) in Italy?
Make the answer very short. -9.63e+1. In the year 1980, what is the difference between the Trade (in US$) of Comoros and Trade (in US$) of St. Vincent and the Grenadines?
Make the answer very short. -2.24e+07. In the year 1980, what is the difference between the Trade (in US$) of France and Trade (in US$) of Italy?
Your answer should be compact. 5.03e+1. In the year 1980, what is the difference between the Trade (in US$) of France and Trade (in US$) of St. Vincent and the Grenadines?
Offer a very short reply. 1.47e+11. In the year 1980, what is the difference between the Trade (in US$) of Italy and Trade (in US$) of St. Vincent and the Grenadines?
Provide a short and direct response. 9.63e+1. In the year 1981, what is the difference between the Trade (in US$) of Comoros and Trade (in US$) of France?
Your answer should be compact. -1.35e+11. In the year 1981, what is the difference between the Trade (in US$) of Comoros and Trade (in US$) of Italy?
Your answer should be very brief. -9.33e+1. In the year 1981, what is the difference between the Trade (in US$) of Comoros and Trade (in US$) of St. Vincent and the Grenadines?
Offer a very short reply. -2.95e+07. In the year 1981, what is the difference between the Trade (in US$) in France and Trade (in US$) in Italy?
Offer a very short reply. 4.14e+1. In the year 1981, what is the difference between the Trade (in US$) of France and Trade (in US$) of St. Vincent and the Grenadines?
Keep it short and to the point. 1.35e+11. In the year 1981, what is the difference between the Trade (in US$) in Italy and Trade (in US$) in St. Vincent and the Grenadines?
Your answer should be very brief. 9.33e+1. In the year 1982, what is the difference between the Trade (in US$) in Comoros and Trade (in US$) in France?
Give a very brief answer. -1.25e+11. In the year 1982, what is the difference between the Trade (in US$) of Comoros and Trade (in US$) of Italy?
Provide a short and direct response. -9.02e+1. In the year 1982, what is the difference between the Trade (in US$) of Comoros and Trade (in US$) of St. Vincent and the Grenadines?
Offer a terse response. -3.35e+07. In the year 1982, what is the difference between the Trade (in US$) of France and Trade (in US$) of Italy?
Ensure brevity in your answer.  3.45e+1. In the year 1982, what is the difference between the Trade (in US$) in France and Trade (in US$) in St. Vincent and the Grenadines?
Your response must be concise. 1.25e+11. In the year 1982, what is the difference between the Trade (in US$) in Italy and Trade (in US$) in St. Vincent and the Grenadines?
Give a very brief answer. 9.02e+1. In the year 1983, what is the difference between the Trade (in US$) in Comoros and Trade (in US$) in France?
Offer a very short reply. -1.25e+11. In the year 1983, what is the difference between the Trade (in US$) of Comoros and Trade (in US$) of Italy?
Provide a short and direct response. -9.00e+1. In the year 1983, what is the difference between the Trade (in US$) in Comoros and Trade (in US$) in St. Vincent and the Grenadines?
Keep it short and to the point. -3.56e+07. In the year 1983, what is the difference between the Trade (in US$) in France and Trade (in US$) in Italy?
Your answer should be very brief. 3.51e+1. In the year 1983, what is the difference between the Trade (in US$) in France and Trade (in US$) in St. Vincent and the Grenadines?
Provide a succinct answer. 1.25e+11. In the year 1983, what is the difference between the Trade (in US$) of Italy and Trade (in US$) of St. Vincent and the Grenadines?
Give a very brief answer. 9.00e+1. In the year 1984, what is the difference between the Trade (in US$) in Comoros and Trade (in US$) in France?
Offer a terse response. -1.26e+11. In the year 1984, what is the difference between the Trade (in US$) of Comoros and Trade (in US$) of Italy?
Give a very brief answer. -9.19e+1. In the year 1984, what is the difference between the Trade (in US$) in Comoros and Trade (in US$) in St. Vincent and the Grenadines?
Provide a succinct answer. -6.18e+07. In the year 1984, what is the difference between the Trade (in US$) of France and Trade (in US$) of Italy?
Offer a terse response. 3.41e+1. In the year 1984, what is the difference between the Trade (in US$) of France and Trade (in US$) of St. Vincent and the Grenadines?
Your response must be concise. 1.26e+11. In the year 1984, what is the difference between the Trade (in US$) in Italy and Trade (in US$) in St. Vincent and the Grenadines?
Your response must be concise. 9.19e+1. In the year 1985, what is the difference between the Trade (in US$) in Comoros and Trade (in US$) in France?
Provide a succinct answer. -1.28e+11. In the year 1985, what is the difference between the Trade (in US$) of Comoros and Trade (in US$) of Italy?
Your answer should be very brief. -9.54e+1. In the year 1985, what is the difference between the Trade (in US$) in Comoros and Trade (in US$) in St. Vincent and the Grenadines?
Give a very brief answer. -6.29e+07. In the year 1985, what is the difference between the Trade (in US$) in France and Trade (in US$) in Italy?
Offer a very short reply. 3.30e+1. In the year 1985, what is the difference between the Trade (in US$) of France and Trade (in US$) of St. Vincent and the Grenadines?
Provide a succinct answer. 1.28e+11. In the year 1985, what is the difference between the Trade (in US$) of Italy and Trade (in US$) of St. Vincent and the Grenadines?
Offer a terse response. 9.54e+1. In the year 1986, what is the difference between the Trade (in US$) in Comoros and Trade (in US$) in France?
Provide a succinct answer. -1.57e+11. In the year 1986, what is the difference between the Trade (in US$) in Comoros and Trade (in US$) in Italy?
Provide a short and direct response. -1.20e+11. In the year 1986, what is the difference between the Trade (in US$) of Comoros and Trade (in US$) of St. Vincent and the Grenadines?
Offer a very short reply. -6.62e+07. In the year 1986, what is the difference between the Trade (in US$) in France and Trade (in US$) in Italy?
Make the answer very short. 3.68e+1. In the year 1986, what is the difference between the Trade (in US$) of France and Trade (in US$) of St. Vincent and the Grenadines?
Give a very brief answer. 1.57e+11. In the year 1986, what is the difference between the Trade (in US$) in Italy and Trade (in US$) in St. Vincent and the Grenadines?
Make the answer very short. 1.20e+11. What is the ratio of the Trade (in US$) in Comoros in 1980 to that in 1981?
Provide a short and direct response. 0.8. What is the ratio of the Trade (in US$) in France in 1980 to that in 1981?
Offer a terse response. 1.09. What is the ratio of the Trade (in US$) of Italy in 1980 to that in 1981?
Provide a succinct answer. 1.03. What is the ratio of the Trade (in US$) of St. Vincent and the Grenadines in 1980 to that in 1981?
Ensure brevity in your answer.  0.77. What is the ratio of the Trade (in US$) of Comoros in 1980 to that in 1982?
Give a very brief answer. 0.64. What is the ratio of the Trade (in US$) in France in 1980 to that in 1982?
Provide a short and direct response. 1.18. What is the ratio of the Trade (in US$) of Italy in 1980 to that in 1982?
Offer a very short reply. 1.07. What is the ratio of the Trade (in US$) of St. Vincent and the Grenadines in 1980 to that in 1982?
Your answer should be very brief. 0.66. What is the ratio of the Trade (in US$) in Comoros in 1980 to that in 1983?
Your answer should be compact. 0.49. What is the ratio of the Trade (in US$) in France in 1980 to that in 1983?
Offer a very short reply. 1.17. What is the ratio of the Trade (in US$) of Italy in 1980 to that in 1983?
Your answer should be very brief. 1.07. What is the ratio of the Trade (in US$) of St. Vincent and the Grenadines in 1980 to that in 1983?
Give a very brief answer. 0.57. What is the ratio of the Trade (in US$) of Comoros in 1980 to that in 1984?
Offer a very short reply. 1.11. What is the ratio of the Trade (in US$) in France in 1980 to that in 1984?
Ensure brevity in your answer.  1.16. What is the ratio of the Trade (in US$) in Italy in 1980 to that in 1984?
Offer a terse response. 1.05. What is the ratio of the Trade (in US$) in St. Vincent and the Grenadines in 1980 to that in 1984?
Give a very brief answer. 0.46. What is the ratio of the Trade (in US$) of Comoros in 1980 to that in 1985?
Provide a short and direct response. 0.55. What is the ratio of the Trade (in US$) of France in 1980 to that in 1985?
Ensure brevity in your answer.  1.14. What is the ratio of the Trade (in US$) of Italy in 1980 to that in 1985?
Keep it short and to the point. 1.01. What is the ratio of the Trade (in US$) in St. Vincent and the Grenadines in 1980 to that in 1985?
Make the answer very short. 0.4. What is the ratio of the Trade (in US$) of Comoros in 1980 to that in 1986?
Your response must be concise. 0.4. What is the ratio of the Trade (in US$) in France in 1980 to that in 1986?
Offer a terse response. 0.94. What is the ratio of the Trade (in US$) in Italy in 1980 to that in 1986?
Ensure brevity in your answer.  0.8. What is the ratio of the Trade (in US$) in St. Vincent and the Grenadines in 1980 to that in 1986?
Your answer should be very brief. 0.36. What is the ratio of the Trade (in US$) of Comoros in 1981 to that in 1982?
Your answer should be very brief. 0.8. What is the ratio of the Trade (in US$) in France in 1981 to that in 1982?
Make the answer very short. 1.08. What is the ratio of the Trade (in US$) of Italy in 1981 to that in 1982?
Provide a succinct answer. 1.03. What is the ratio of the Trade (in US$) in St. Vincent and the Grenadines in 1981 to that in 1982?
Make the answer very short. 0.85. What is the ratio of the Trade (in US$) in Comoros in 1981 to that in 1983?
Offer a very short reply. 0.61. What is the ratio of the Trade (in US$) of France in 1981 to that in 1983?
Your answer should be very brief. 1.08. What is the ratio of the Trade (in US$) of Italy in 1981 to that in 1983?
Provide a succinct answer. 1.04. What is the ratio of the Trade (in US$) of St. Vincent and the Grenadines in 1981 to that in 1983?
Provide a short and direct response. 0.74. What is the ratio of the Trade (in US$) in Comoros in 1981 to that in 1984?
Give a very brief answer. 1.39. What is the ratio of the Trade (in US$) in France in 1981 to that in 1984?
Offer a terse response. 1.07. What is the ratio of the Trade (in US$) in Italy in 1981 to that in 1984?
Your answer should be very brief. 1.01. What is the ratio of the Trade (in US$) of St. Vincent and the Grenadines in 1981 to that in 1984?
Ensure brevity in your answer.  0.6. What is the ratio of the Trade (in US$) in Comoros in 1981 to that in 1985?
Your response must be concise. 0.69. What is the ratio of the Trade (in US$) in France in 1981 to that in 1985?
Your answer should be very brief. 1.05. What is the ratio of the Trade (in US$) of Italy in 1981 to that in 1985?
Offer a terse response. 0.98. What is the ratio of the Trade (in US$) of St. Vincent and the Grenadines in 1981 to that in 1985?
Ensure brevity in your answer.  0.52. What is the ratio of the Trade (in US$) of Comoros in 1981 to that in 1986?
Give a very brief answer. 0.5. What is the ratio of the Trade (in US$) in France in 1981 to that in 1986?
Ensure brevity in your answer.  0.86. What is the ratio of the Trade (in US$) in Italy in 1981 to that in 1986?
Offer a very short reply. 0.78. What is the ratio of the Trade (in US$) of St. Vincent and the Grenadines in 1981 to that in 1986?
Your response must be concise. 0.46. What is the ratio of the Trade (in US$) of Comoros in 1982 to that in 1983?
Offer a terse response. 0.76. What is the ratio of the Trade (in US$) in St. Vincent and the Grenadines in 1982 to that in 1983?
Offer a very short reply. 0.87. What is the ratio of the Trade (in US$) in Comoros in 1982 to that in 1984?
Your answer should be compact. 1.73. What is the ratio of the Trade (in US$) of France in 1982 to that in 1984?
Ensure brevity in your answer.  0.99. What is the ratio of the Trade (in US$) in Italy in 1982 to that in 1984?
Provide a succinct answer. 0.98. What is the ratio of the Trade (in US$) of St. Vincent and the Grenadines in 1982 to that in 1984?
Offer a terse response. 0.7. What is the ratio of the Trade (in US$) of Comoros in 1982 to that in 1985?
Ensure brevity in your answer.  0.86. What is the ratio of the Trade (in US$) in France in 1982 to that in 1985?
Keep it short and to the point. 0.97. What is the ratio of the Trade (in US$) of Italy in 1982 to that in 1985?
Your answer should be compact. 0.95. What is the ratio of the Trade (in US$) in St. Vincent and the Grenadines in 1982 to that in 1985?
Your response must be concise. 0.61. What is the ratio of the Trade (in US$) in Comoros in 1982 to that in 1986?
Provide a short and direct response. 0.63. What is the ratio of the Trade (in US$) of France in 1982 to that in 1986?
Offer a terse response. 0.8. What is the ratio of the Trade (in US$) of Italy in 1982 to that in 1986?
Give a very brief answer. 0.75. What is the ratio of the Trade (in US$) in St. Vincent and the Grenadines in 1982 to that in 1986?
Provide a succinct answer. 0.54. What is the ratio of the Trade (in US$) of Comoros in 1983 to that in 1984?
Give a very brief answer. 2.28. What is the ratio of the Trade (in US$) in France in 1983 to that in 1984?
Your response must be concise. 0.99. What is the ratio of the Trade (in US$) in Italy in 1983 to that in 1984?
Provide a succinct answer. 0.98. What is the ratio of the Trade (in US$) in St. Vincent and the Grenadines in 1983 to that in 1984?
Give a very brief answer. 0.81. What is the ratio of the Trade (in US$) of Comoros in 1983 to that in 1985?
Offer a terse response. 1.14. What is the ratio of the Trade (in US$) of France in 1983 to that in 1985?
Keep it short and to the point. 0.97. What is the ratio of the Trade (in US$) in Italy in 1983 to that in 1985?
Provide a succinct answer. 0.94. What is the ratio of the Trade (in US$) of Comoros in 1983 to that in 1986?
Ensure brevity in your answer.  0.83. What is the ratio of the Trade (in US$) in France in 1983 to that in 1986?
Offer a very short reply. 0.8. What is the ratio of the Trade (in US$) in Italy in 1983 to that in 1986?
Offer a very short reply. 0.75. What is the ratio of the Trade (in US$) in St. Vincent and the Grenadines in 1983 to that in 1986?
Provide a short and direct response. 0.62. What is the ratio of the Trade (in US$) of Comoros in 1984 to that in 1985?
Give a very brief answer. 0.5. What is the ratio of the Trade (in US$) in France in 1984 to that in 1985?
Offer a terse response. 0.98. What is the ratio of the Trade (in US$) of Italy in 1984 to that in 1985?
Your answer should be very brief. 0.96. What is the ratio of the Trade (in US$) of St. Vincent and the Grenadines in 1984 to that in 1985?
Offer a very short reply. 0.87. What is the ratio of the Trade (in US$) of Comoros in 1984 to that in 1986?
Offer a very short reply. 0.36. What is the ratio of the Trade (in US$) of France in 1984 to that in 1986?
Offer a terse response. 0.8. What is the ratio of the Trade (in US$) in Italy in 1984 to that in 1986?
Offer a terse response. 0.77. What is the ratio of the Trade (in US$) in St. Vincent and the Grenadines in 1984 to that in 1986?
Give a very brief answer. 0.77. What is the ratio of the Trade (in US$) in Comoros in 1985 to that in 1986?
Ensure brevity in your answer.  0.73. What is the ratio of the Trade (in US$) of France in 1985 to that in 1986?
Provide a short and direct response. 0.82. What is the ratio of the Trade (in US$) of Italy in 1985 to that in 1986?
Your response must be concise. 0.8. What is the ratio of the Trade (in US$) of St. Vincent and the Grenadines in 1985 to that in 1986?
Your answer should be compact. 0.89. What is the difference between the highest and the second highest Trade (in US$) in Comoros?
Give a very brief answer. 4.60e+06. What is the difference between the highest and the second highest Trade (in US$) of France?
Provide a succinct answer. 9.95e+09. What is the difference between the highest and the second highest Trade (in US$) in Italy?
Your answer should be compact. 2.34e+1. What is the difference between the highest and the second highest Trade (in US$) in St. Vincent and the Grenadines?
Make the answer very short. 1.05e+07. What is the difference between the highest and the lowest Trade (in US$) of Comoros?
Provide a succinct answer. 1.70e+07. What is the difference between the highest and the lowest Trade (in US$) of France?
Give a very brief answer. 3.19e+1. What is the difference between the highest and the lowest Trade (in US$) of Italy?
Make the answer very short. 2.97e+1. What is the difference between the highest and the lowest Trade (in US$) of St. Vincent and the Grenadines?
Give a very brief answer. 5.98e+07. 